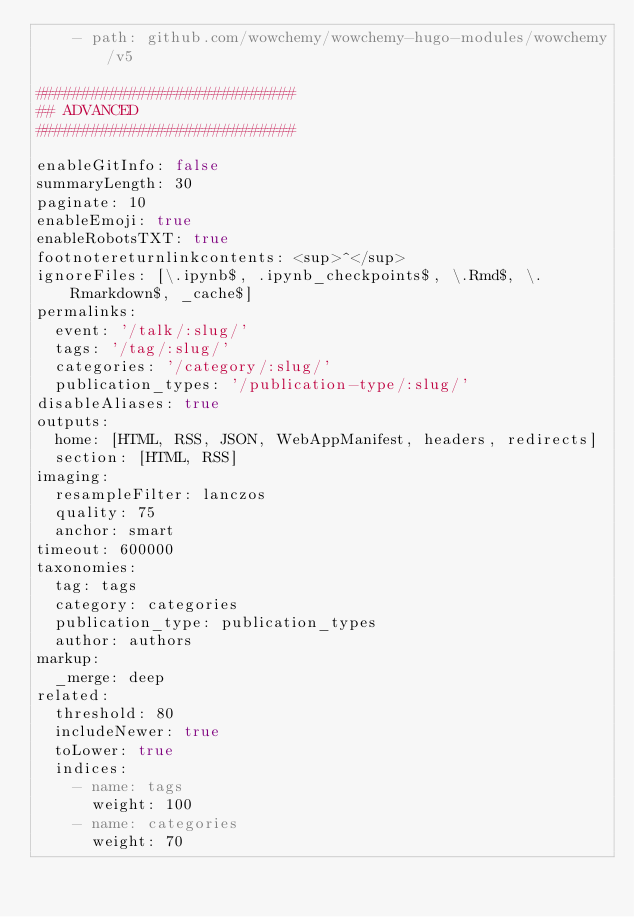Convert code to text. <code><loc_0><loc_0><loc_500><loc_500><_YAML_>    - path: github.com/wowchemy/wowchemy-hugo-modules/wowchemy/v5

############################
## ADVANCED
############################

enableGitInfo: false
summaryLength: 30
paginate: 10
enableEmoji: true
enableRobotsTXT: true
footnotereturnlinkcontents: <sup>^</sup>
ignoreFiles: [\.ipynb$, .ipynb_checkpoints$, \.Rmd$, \.Rmarkdown$, _cache$]
permalinks:
  event: '/talk/:slug/'
  tags: '/tag/:slug/'
  categories: '/category/:slug/'
  publication_types: '/publication-type/:slug/'
disableAliases: true
outputs:
  home: [HTML, RSS, JSON, WebAppManifest, headers, redirects]
  section: [HTML, RSS]
imaging:
  resampleFilter: lanczos
  quality: 75
  anchor: smart
timeout: 600000
taxonomies:
  tag: tags
  category: categories
  publication_type: publication_types
  author: authors
markup:
  _merge: deep
related:
  threshold: 80
  includeNewer: true
  toLower: true
  indices:
    - name: tags
      weight: 100
    - name: categories
      weight: 70
</code> 